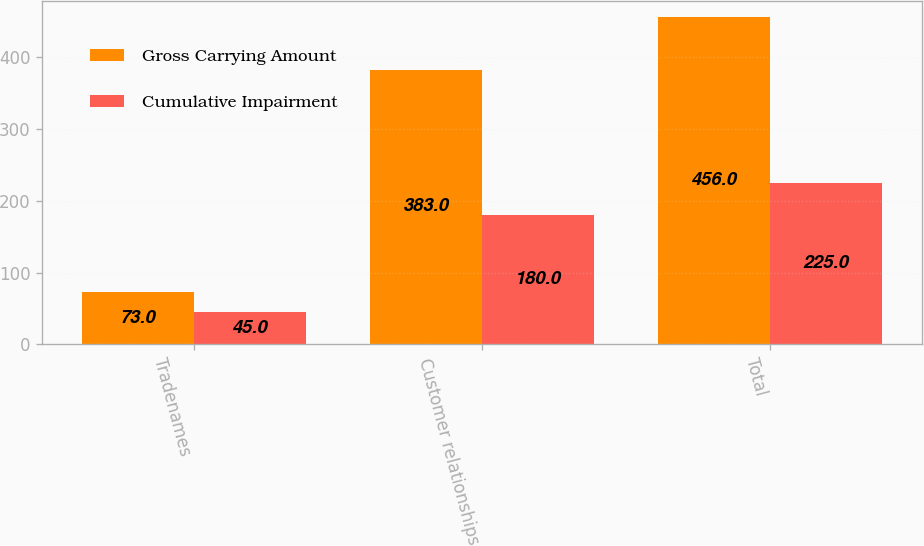Convert chart to OTSL. <chart><loc_0><loc_0><loc_500><loc_500><stacked_bar_chart><ecel><fcel>Tradenames<fcel>Customer relationships<fcel>Total<nl><fcel>Gross Carrying Amount<fcel>73<fcel>383<fcel>456<nl><fcel>Cumulative Impairment<fcel>45<fcel>180<fcel>225<nl></chart> 